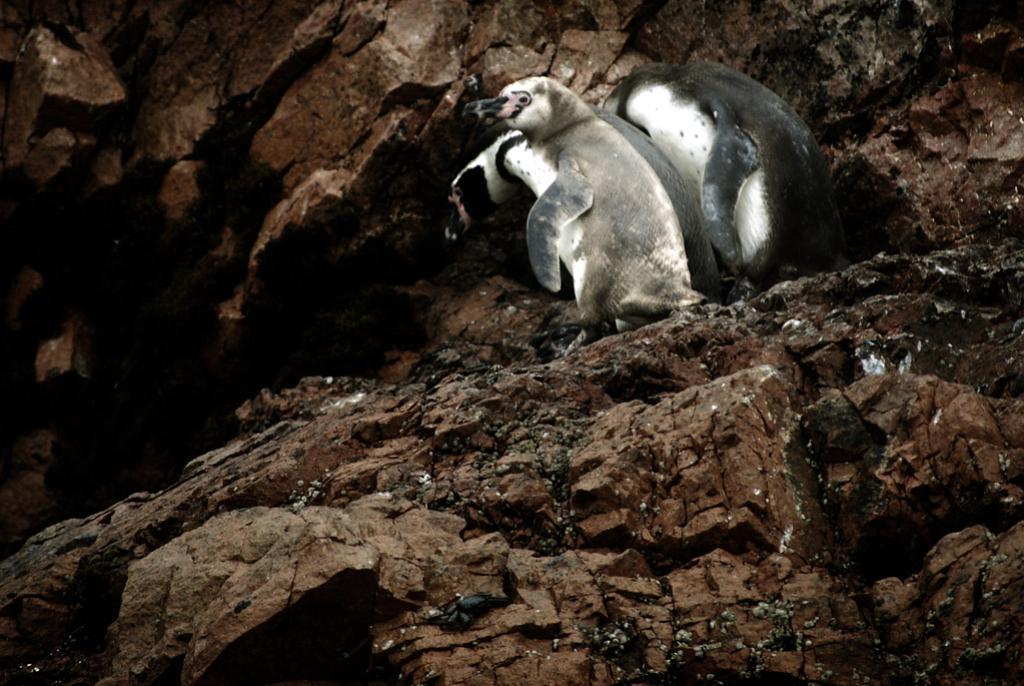Please provide a concise description of this image. In this picture there are penguins at the top side of the image, on the rocks and there are rocks around the area of the image. 